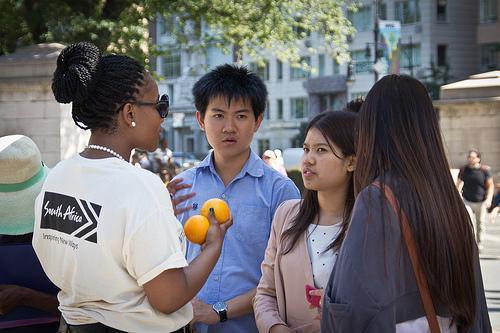How many oranges are in the picture?
Give a very brief answer. 2. How many women have their hair down?
Give a very brief answer. 2. 